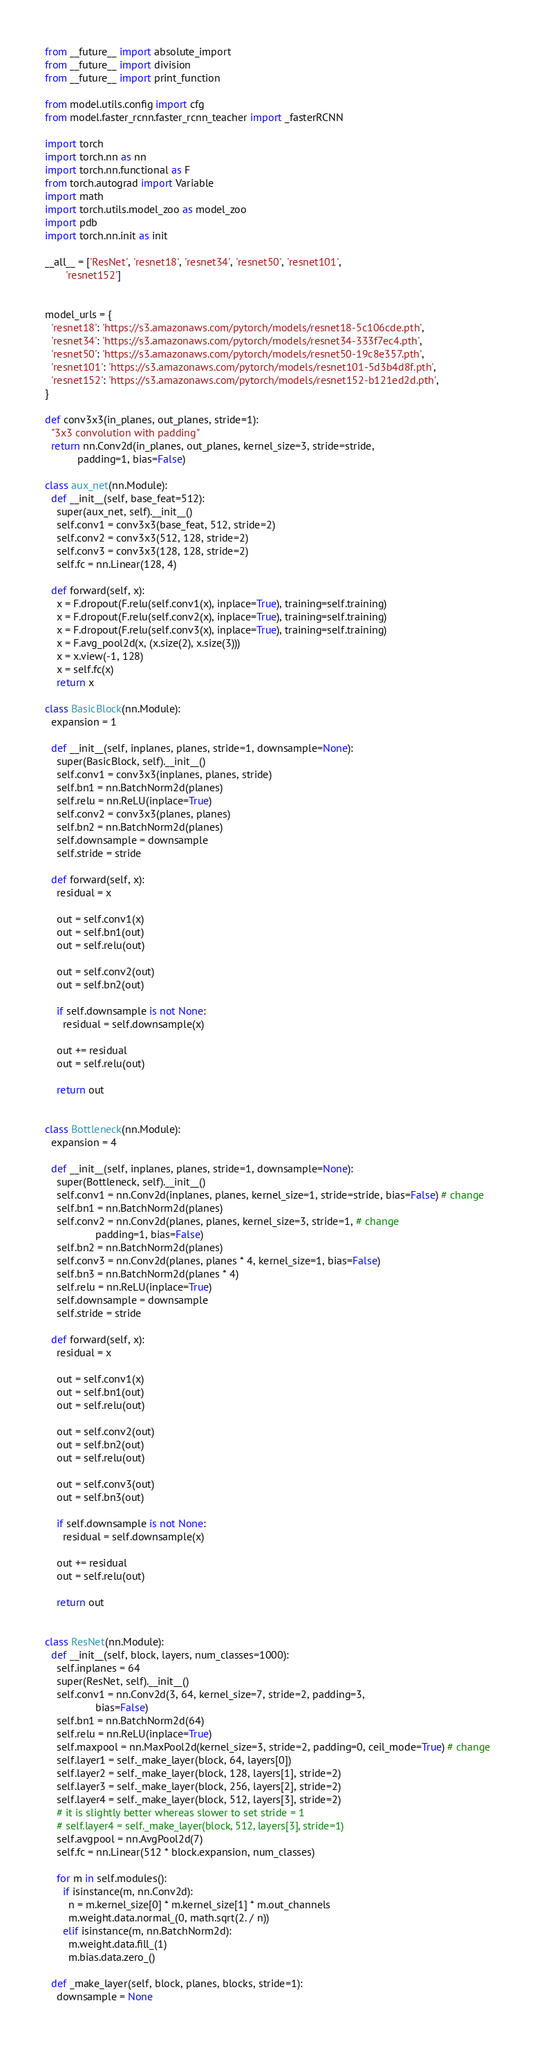Convert code to text. <code><loc_0><loc_0><loc_500><loc_500><_Python_>from __future__ import absolute_import
from __future__ import division
from __future__ import print_function

from model.utils.config import cfg
from model.faster_rcnn.faster_rcnn_teacher import _fasterRCNN

import torch
import torch.nn as nn
import torch.nn.functional as F
from torch.autograd import Variable
import math
import torch.utils.model_zoo as model_zoo
import pdb
import torch.nn.init as init

__all__ = ['ResNet', 'resnet18', 'resnet34', 'resnet50', 'resnet101',
       'resnet152']


model_urls = {
  'resnet18': 'https://s3.amazonaws.com/pytorch/models/resnet18-5c106cde.pth',
  'resnet34': 'https://s3.amazonaws.com/pytorch/models/resnet34-333f7ec4.pth',
  'resnet50': 'https://s3.amazonaws.com/pytorch/models/resnet50-19c8e357.pth',
  'resnet101': 'https://s3.amazonaws.com/pytorch/models/resnet101-5d3b4d8f.pth',
  'resnet152': 'https://s3.amazonaws.com/pytorch/models/resnet152-b121ed2d.pth',
}

def conv3x3(in_planes, out_planes, stride=1):
  "3x3 convolution with padding"
  return nn.Conv2d(in_planes, out_planes, kernel_size=3, stride=stride,
           padding=1, bias=False)

class aux_net(nn.Module):
  def __init__(self, base_feat=512):
    super(aux_net, self).__init__()
    self.conv1 = conv3x3(base_feat, 512, stride=2)
    self.conv2 = conv3x3(512, 128, stride=2)
    self.conv3 = conv3x3(128, 128, stride=2)
    self.fc = nn.Linear(128, 4)

  def forward(self, x):
    x = F.dropout(F.relu(self.conv1(x), inplace=True), training=self.training)
    x = F.dropout(F.relu(self.conv2(x), inplace=True), training=self.training)
    x = F.dropout(F.relu(self.conv3(x), inplace=True), training=self.training)
    x = F.avg_pool2d(x, (x.size(2), x.size(3)))
    x = x.view(-1, 128)
    x = self.fc(x)
    return x

class BasicBlock(nn.Module):
  expansion = 1

  def __init__(self, inplanes, planes, stride=1, downsample=None):
    super(BasicBlock, self).__init__()
    self.conv1 = conv3x3(inplanes, planes, stride)
    self.bn1 = nn.BatchNorm2d(planes)
    self.relu = nn.ReLU(inplace=True)
    self.conv2 = conv3x3(planes, planes)
    self.bn2 = nn.BatchNorm2d(planes)
    self.downsample = downsample
    self.stride = stride

  def forward(self, x):
    residual = x

    out = self.conv1(x)
    out = self.bn1(out)
    out = self.relu(out)

    out = self.conv2(out)
    out = self.bn2(out)

    if self.downsample is not None:
      residual = self.downsample(x)

    out += residual
    out = self.relu(out)

    return out


class Bottleneck(nn.Module):
  expansion = 4

  def __init__(self, inplanes, planes, stride=1, downsample=None):
    super(Bottleneck, self).__init__()
    self.conv1 = nn.Conv2d(inplanes, planes, kernel_size=1, stride=stride, bias=False) # change
    self.bn1 = nn.BatchNorm2d(planes)
    self.conv2 = nn.Conv2d(planes, planes, kernel_size=3, stride=1, # change
                 padding=1, bias=False)
    self.bn2 = nn.BatchNorm2d(planes)
    self.conv3 = nn.Conv2d(planes, planes * 4, kernel_size=1, bias=False)
    self.bn3 = nn.BatchNorm2d(planes * 4)
    self.relu = nn.ReLU(inplace=True)
    self.downsample = downsample
    self.stride = stride

  def forward(self, x):
    residual = x

    out = self.conv1(x)
    out = self.bn1(out)
    out = self.relu(out)

    out = self.conv2(out)
    out = self.bn2(out)
    out = self.relu(out)

    out = self.conv3(out)
    out = self.bn3(out)

    if self.downsample is not None:
      residual = self.downsample(x)

    out += residual
    out = self.relu(out)

    return out


class ResNet(nn.Module):
  def __init__(self, block, layers, num_classes=1000):
    self.inplanes = 64
    super(ResNet, self).__init__()
    self.conv1 = nn.Conv2d(3, 64, kernel_size=7, stride=2, padding=3,
                 bias=False)
    self.bn1 = nn.BatchNorm2d(64)
    self.relu = nn.ReLU(inplace=True)
    self.maxpool = nn.MaxPool2d(kernel_size=3, stride=2, padding=0, ceil_mode=True) # change
    self.layer1 = self._make_layer(block, 64, layers[0])
    self.layer2 = self._make_layer(block, 128, layers[1], stride=2)
    self.layer3 = self._make_layer(block, 256, layers[2], stride=2)
    self.layer4 = self._make_layer(block, 512, layers[3], stride=2)
    # it is slightly better whereas slower to set stride = 1
    # self.layer4 = self._make_layer(block, 512, layers[3], stride=1)
    self.avgpool = nn.AvgPool2d(7)
    self.fc = nn.Linear(512 * block.expansion, num_classes)

    for m in self.modules():
      if isinstance(m, nn.Conv2d):
        n = m.kernel_size[0] * m.kernel_size[1] * m.out_channels
        m.weight.data.normal_(0, math.sqrt(2. / n))
      elif isinstance(m, nn.BatchNorm2d):
        m.weight.data.fill_(1)
        m.bias.data.zero_()

  def _make_layer(self, block, planes, blocks, stride=1):
    downsample = None</code> 